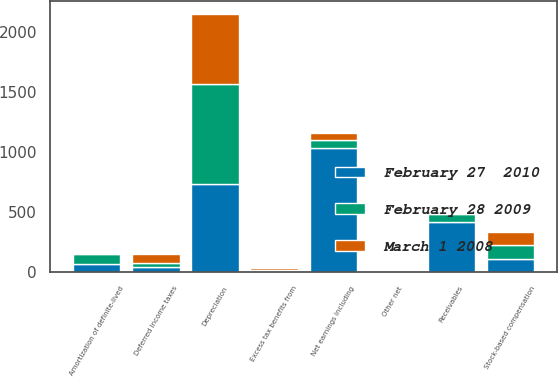Convert chart. <chart><loc_0><loc_0><loc_500><loc_500><stacked_bar_chart><ecel><fcel>Net earnings including<fcel>Depreciation<fcel>Amortization of definite-lived<fcel>Stock-based compensation<fcel>Deferred income taxes<fcel>Excess tax benefits from<fcel>Other net<fcel>Receivables<nl><fcel>February 28 2009<fcel>63<fcel>838<fcel>88<fcel>118<fcel>30<fcel>7<fcel>4<fcel>63<nl><fcel>February 27  2010<fcel>1033<fcel>730<fcel>63<fcel>110<fcel>43<fcel>6<fcel>12<fcel>419<nl><fcel>March 1 2008<fcel>63<fcel>580<fcel>1<fcel>105<fcel>74<fcel>24<fcel>7<fcel>12<nl></chart> 